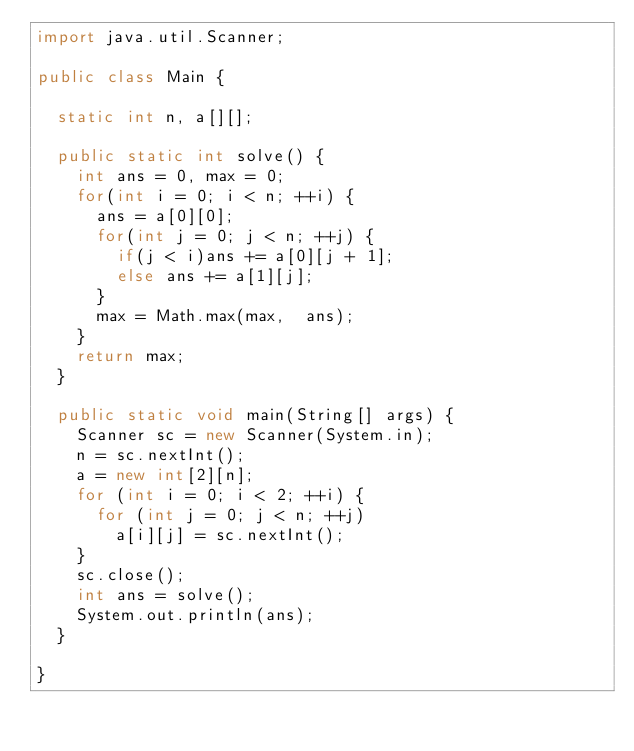<code> <loc_0><loc_0><loc_500><loc_500><_Java_>import java.util.Scanner;

public class Main {

	static int n, a[][];

	public static int solve() {
		int ans = 0, max = 0;
		for(int i = 0; i < n; ++i) {
			ans = a[0][0];
			for(int j = 0; j < n; ++j) {
				if(j < i)ans += a[0][j + 1];
				else ans += a[1][j];
			}
			max = Math.max(max,  ans);
		}
		return max;
	}

	public static void main(String[] args) {
		Scanner sc = new Scanner(System.in);
		n = sc.nextInt();
		a = new int[2][n];
		for (int i = 0; i < 2; ++i) {
			for (int j = 0; j < n; ++j)
				a[i][j] = sc.nextInt();
		}
		sc.close();
		int ans = solve();
		System.out.println(ans);
	}

}
</code> 